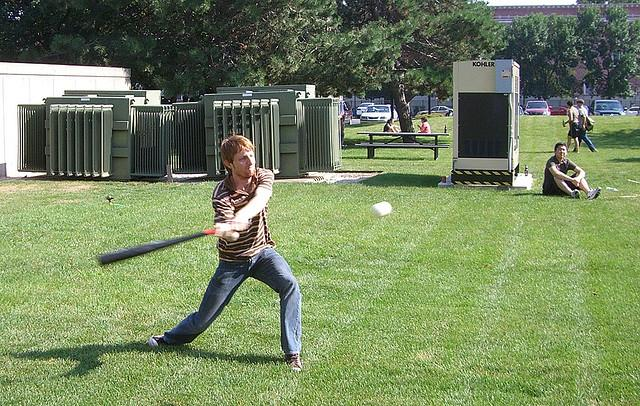What does the unit named Kohler provide? Please explain your reasoning. air conditioning. Water (d). the brand specializes in home and plumbing, most directly related to water. 